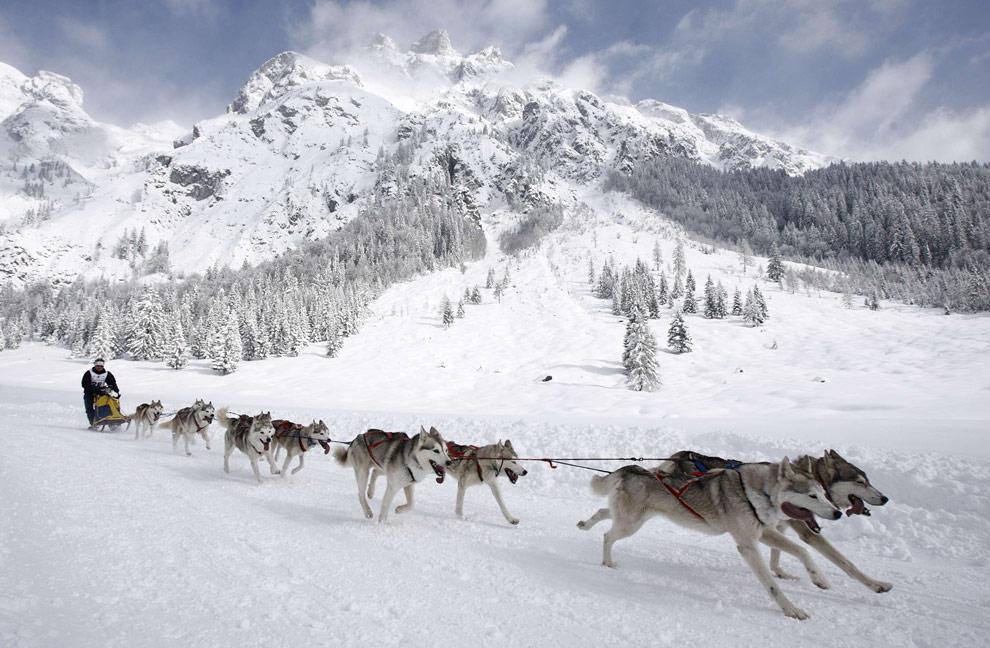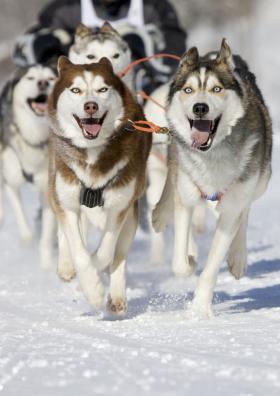The first image is the image on the left, the second image is the image on the right. Analyze the images presented: Is the assertion "The image on the left has more than six dogs pulling the sleigh." valid? Answer yes or no. Yes. The first image is the image on the left, the second image is the image on the right. Evaluate the accuracy of this statement regarding the images: "There is a person visible behind a pack of huskies.". Is it true? Answer yes or no. Yes. 